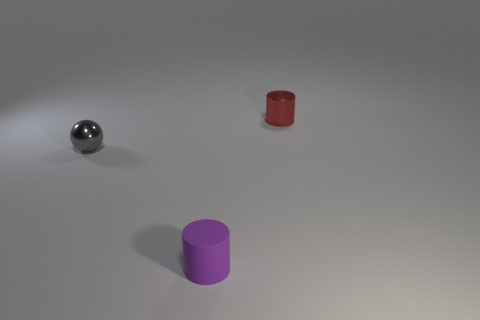Add 3 tiny red objects. How many objects exist? 6 Subtract all cylinders. How many objects are left? 1 Subtract 0 blue cylinders. How many objects are left? 3 Subtract all small matte blocks. Subtract all tiny shiny things. How many objects are left? 1 Add 2 tiny metallic balls. How many tiny metallic balls are left? 3 Add 1 tiny rubber cylinders. How many tiny rubber cylinders exist? 2 